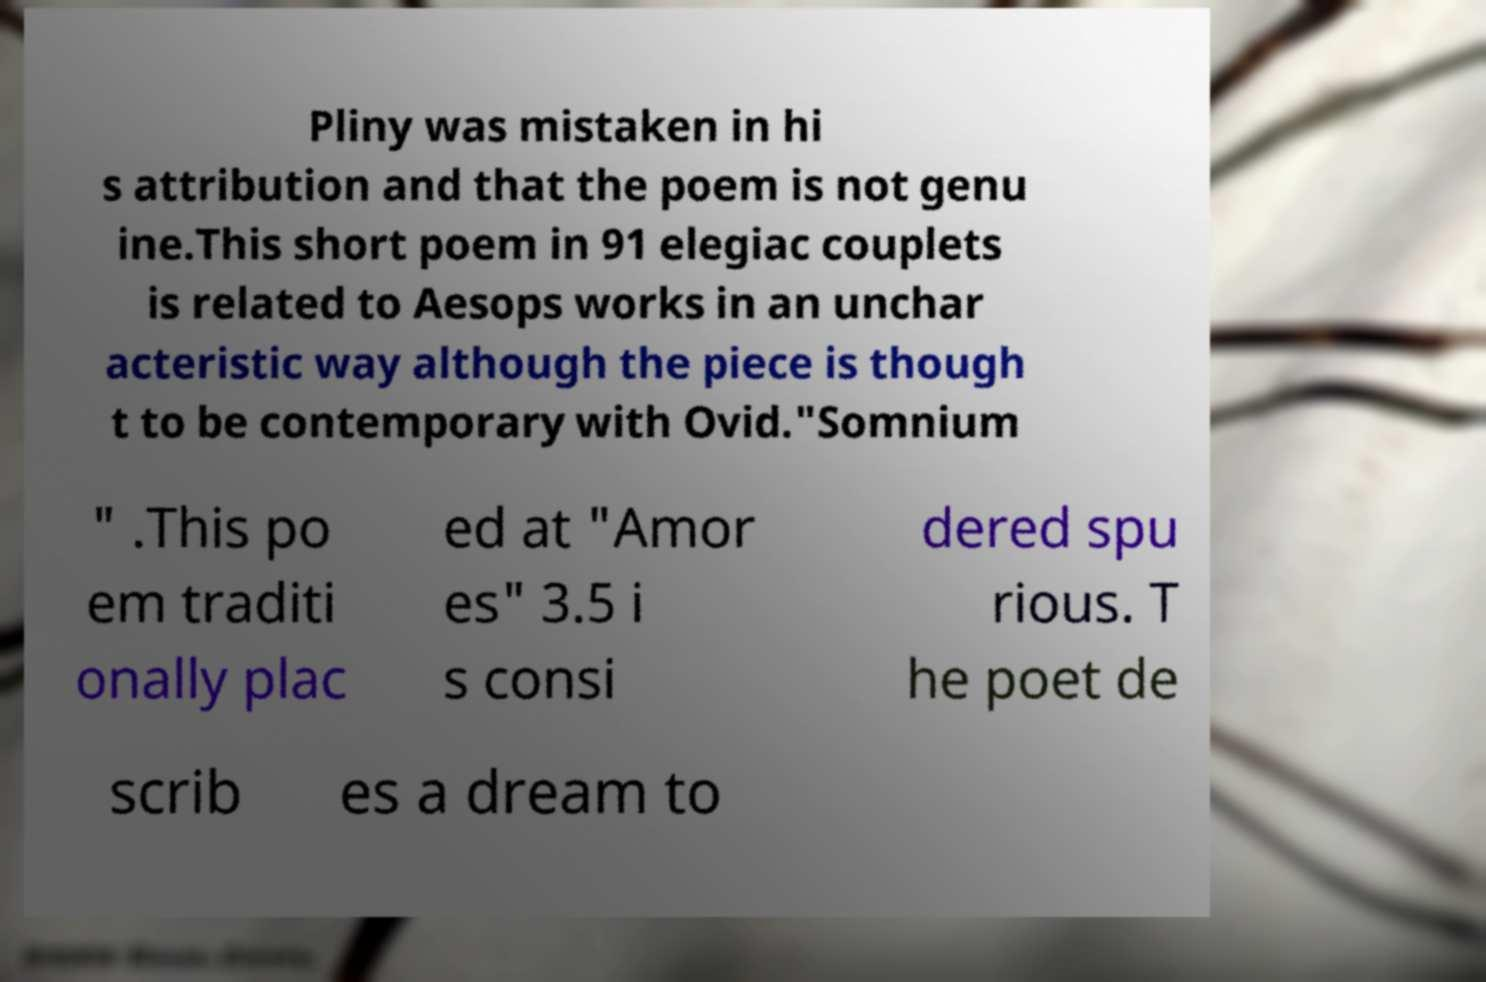What messages or text are displayed in this image? I need them in a readable, typed format. Pliny was mistaken in hi s attribution and that the poem is not genu ine.This short poem in 91 elegiac couplets is related to Aesops works in an unchar acteristic way although the piece is though t to be contemporary with Ovid."Somnium " .This po em traditi onally plac ed at "Amor es" 3.5 i s consi dered spu rious. T he poet de scrib es a dream to 